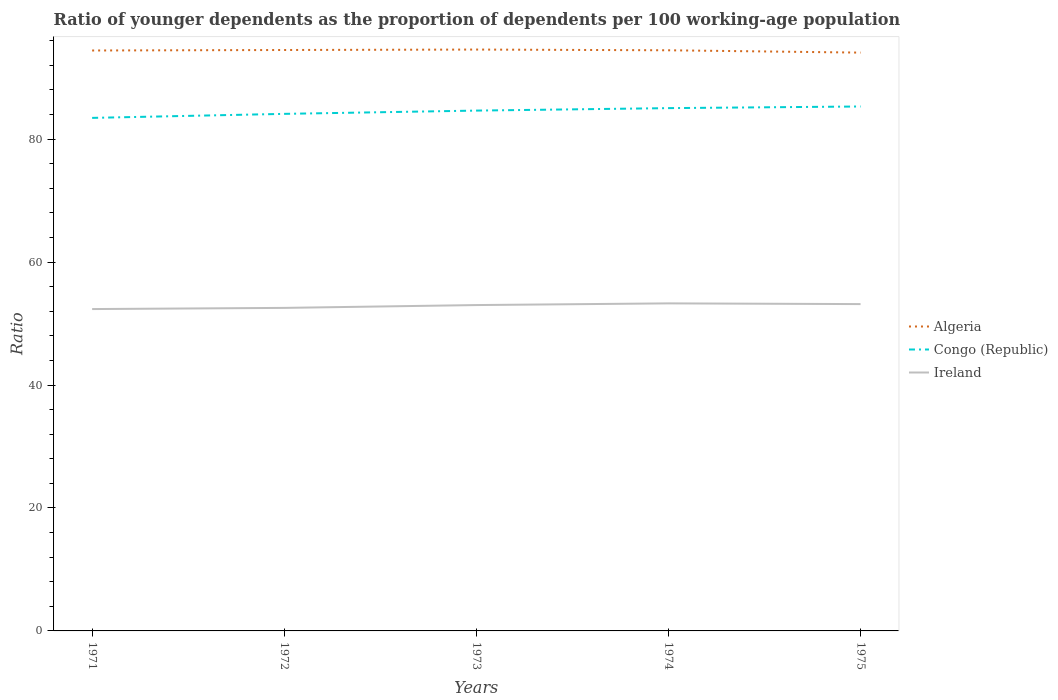Across all years, what is the maximum age dependency ratio(young) in Congo (Republic)?
Ensure brevity in your answer.  83.46. In which year was the age dependency ratio(young) in Congo (Republic) maximum?
Your response must be concise. 1971. What is the total age dependency ratio(young) in Congo (Republic) in the graph?
Ensure brevity in your answer.  -1.19. What is the difference between the highest and the second highest age dependency ratio(young) in Algeria?
Your answer should be very brief. 0.5. How many years are there in the graph?
Your answer should be compact. 5. What is the difference between two consecutive major ticks on the Y-axis?
Give a very brief answer. 20. Are the values on the major ticks of Y-axis written in scientific E-notation?
Your response must be concise. No. Does the graph contain grids?
Offer a terse response. No. Where does the legend appear in the graph?
Your response must be concise. Center right. How many legend labels are there?
Your answer should be very brief. 3. What is the title of the graph?
Your answer should be compact. Ratio of younger dependents as the proportion of dependents per 100 working-age population. Does "Indonesia" appear as one of the legend labels in the graph?
Offer a terse response. No. What is the label or title of the Y-axis?
Give a very brief answer. Ratio. What is the Ratio of Algeria in 1971?
Your answer should be very brief. 94.42. What is the Ratio of Congo (Republic) in 1971?
Give a very brief answer. 83.46. What is the Ratio of Ireland in 1971?
Offer a very short reply. 52.36. What is the Ratio of Algeria in 1972?
Offer a terse response. 94.5. What is the Ratio of Congo (Republic) in 1972?
Make the answer very short. 84.11. What is the Ratio of Ireland in 1972?
Keep it short and to the point. 52.55. What is the Ratio of Algeria in 1973?
Your answer should be compact. 94.57. What is the Ratio of Congo (Republic) in 1973?
Ensure brevity in your answer.  84.64. What is the Ratio of Ireland in 1973?
Give a very brief answer. 53.01. What is the Ratio in Algeria in 1974?
Give a very brief answer. 94.45. What is the Ratio in Congo (Republic) in 1974?
Provide a succinct answer. 85.04. What is the Ratio in Ireland in 1974?
Keep it short and to the point. 53.28. What is the Ratio in Algeria in 1975?
Ensure brevity in your answer.  94.07. What is the Ratio of Congo (Republic) in 1975?
Offer a very short reply. 85.31. What is the Ratio in Ireland in 1975?
Your response must be concise. 53.17. Across all years, what is the maximum Ratio in Algeria?
Provide a succinct answer. 94.57. Across all years, what is the maximum Ratio in Congo (Republic)?
Offer a very short reply. 85.31. Across all years, what is the maximum Ratio of Ireland?
Ensure brevity in your answer.  53.28. Across all years, what is the minimum Ratio in Algeria?
Your response must be concise. 94.07. Across all years, what is the minimum Ratio of Congo (Republic)?
Make the answer very short. 83.46. Across all years, what is the minimum Ratio of Ireland?
Provide a succinct answer. 52.36. What is the total Ratio of Algeria in the graph?
Provide a short and direct response. 472.02. What is the total Ratio of Congo (Republic) in the graph?
Offer a terse response. 422.57. What is the total Ratio in Ireland in the graph?
Make the answer very short. 264.36. What is the difference between the Ratio of Algeria in 1971 and that in 1972?
Your answer should be compact. -0.08. What is the difference between the Ratio of Congo (Republic) in 1971 and that in 1972?
Keep it short and to the point. -0.65. What is the difference between the Ratio of Ireland in 1971 and that in 1972?
Provide a short and direct response. -0.19. What is the difference between the Ratio in Algeria in 1971 and that in 1973?
Your response must be concise. -0.15. What is the difference between the Ratio of Congo (Republic) in 1971 and that in 1973?
Keep it short and to the point. -1.19. What is the difference between the Ratio of Ireland in 1971 and that in 1973?
Provide a succinct answer. -0.65. What is the difference between the Ratio of Algeria in 1971 and that in 1974?
Make the answer very short. -0.03. What is the difference between the Ratio of Congo (Republic) in 1971 and that in 1974?
Offer a terse response. -1.59. What is the difference between the Ratio of Ireland in 1971 and that in 1974?
Ensure brevity in your answer.  -0.92. What is the difference between the Ratio in Algeria in 1971 and that in 1975?
Your response must be concise. 0.35. What is the difference between the Ratio in Congo (Republic) in 1971 and that in 1975?
Provide a succinct answer. -1.85. What is the difference between the Ratio in Ireland in 1971 and that in 1975?
Keep it short and to the point. -0.81. What is the difference between the Ratio in Algeria in 1972 and that in 1973?
Your answer should be very brief. -0.07. What is the difference between the Ratio in Congo (Republic) in 1972 and that in 1973?
Your answer should be compact. -0.53. What is the difference between the Ratio of Ireland in 1972 and that in 1973?
Make the answer very short. -0.46. What is the difference between the Ratio in Algeria in 1972 and that in 1974?
Provide a short and direct response. 0.05. What is the difference between the Ratio in Congo (Republic) in 1972 and that in 1974?
Offer a terse response. -0.93. What is the difference between the Ratio of Ireland in 1972 and that in 1974?
Your response must be concise. -0.74. What is the difference between the Ratio of Algeria in 1972 and that in 1975?
Offer a terse response. 0.43. What is the difference between the Ratio of Congo (Republic) in 1972 and that in 1975?
Ensure brevity in your answer.  -1.2. What is the difference between the Ratio in Ireland in 1972 and that in 1975?
Give a very brief answer. -0.62. What is the difference between the Ratio of Algeria in 1973 and that in 1974?
Offer a terse response. 0.12. What is the difference between the Ratio of Congo (Republic) in 1973 and that in 1974?
Your answer should be compact. -0.4. What is the difference between the Ratio in Ireland in 1973 and that in 1974?
Make the answer very short. -0.27. What is the difference between the Ratio in Algeria in 1973 and that in 1975?
Provide a short and direct response. 0.5. What is the difference between the Ratio of Congo (Republic) in 1973 and that in 1975?
Offer a terse response. -0.67. What is the difference between the Ratio of Ireland in 1973 and that in 1975?
Give a very brief answer. -0.16. What is the difference between the Ratio in Algeria in 1974 and that in 1975?
Make the answer very short. 0.38. What is the difference between the Ratio of Congo (Republic) in 1974 and that in 1975?
Keep it short and to the point. -0.27. What is the difference between the Ratio of Ireland in 1974 and that in 1975?
Your answer should be very brief. 0.12. What is the difference between the Ratio of Algeria in 1971 and the Ratio of Congo (Republic) in 1972?
Make the answer very short. 10.31. What is the difference between the Ratio of Algeria in 1971 and the Ratio of Ireland in 1972?
Offer a very short reply. 41.87. What is the difference between the Ratio in Congo (Republic) in 1971 and the Ratio in Ireland in 1972?
Give a very brief answer. 30.91. What is the difference between the Ratio in Algeria in 1971 and the Ratio in Congo (Republic) in 1973?
Provide a short and direct response. 9.78. What is the difference between the Ratio of Algeria in 1971 and the Ratio of Ireland in 1973?
Make the answer very short. 41.41. What is the difference between the Ratio of Congo (Republic) in 1971 and the Ratio of Ireland in 1973?
Provide a short and direct response. 30.45. What is the difference between the Ratio in Algeria in 1971 and the Ratio in Congo (Republic) in 1974?
Your answer should be compact. 9.38. What is the difference between the Ratio of Algeria in 1971 and the Ratio of Ireland in 1974?
Keep it short and to the point. 41.14. What is the difference between the Ratio in Congo (Republic) in 1971 and the Ratio in Ireland in 1974?
Give a very brief answer. 30.17. What is the difference between the Ratio in Algeria in 1971 and the Ratio in Congo (Republic) in 1975?
Ensure brevity in your answer.  9.11. What is the difference between the Ratio of Algeria in 1971 and the Ratio of Ireland in 1975?
Offer a terse response. 41.25. What is the difference between the Ratio in Congo (Republic) in 1971 and the Ratio in Ireland in 1975?
Provide a succinct answer. 30.29. What is the difference between the Ratio of Algeria in 1972 and the Ratio of Congo (Republic) in 1973?
Give a very brief answer. 9.86. What is the difference between the Ratio of Algeria in 1972 and the Ratio of Ireland in 1973?
Offer a very short reply. 41.49. What is the difference between the Ratio in Congo (Republic) in 1972 and the Ratio in Ireland in 1973?
Provide a succinct answer. 31.1. What is the difference between the Ratio of Algeria in 1972 and the Ratio of Congo (Republic) in 1974?
Your response must be concise. 9.46. What is the difference between the Ratio of Algeria in 1972 and the Ratio of Ireland in 1974?
Ensure brevity in your answer.  41.22. What is the difference between the Ratio in Congo (Republic) in 1972 and the Ratio in Ireland in 1974?
Provide a short and direct response. 30.83. What is the difference between the Ratio in Algeria in 1972 and the Ratio in Congo (Republic) in 1975?
Offer a very short reply. 9.19. What is the difference between the Ratio of Algeria in 1972 and the Ratio of Ireland in 1975?
Provide a succinct answer. 41.34. What is the difference between the Ratio in Congo (Republic) in 1972 and the Ratio in Ireland in 1975?
Give a very brief answer. 30.95. What is the difference between the Ratio of Algeria in 1973 and the Ratio of Congo (Republic) in 1974?
Offer a very short reply. 9.53. What is the difference between the Ratio of Algeria in 1973 and the Ratio of Ireland in 1974?
Your answer should be compact. 41.29. What is the difference between the Ratio in Congo (Republic) in 1973 and the Ratio in Ireland in 1974?
Your answer should be very brief. 31.36. What is the difference between the Ratio in Algeria in 1973 and the Ratio in Congo (Republic) in 1975?
Keep it short and to the point. 9.26. What is the difference between the Ratio in Algeria in 1973 and the Ratio in Ireland in 1975?
Give a very brief answer. 41.41. What is the difference between the Ratio of Congo (Republic) in 1973 and the Ratio of Ireland in 1975?
Give a very brief answer. 31.48. What is the difference between the Ratio in Algeria in 1974 and the Ratio in Congo (Republic) in 1975?
Offer a very short reply. 9.14. What is the difference between the Ratio in Algeria in 1974 and the Ratio in Ireland in 1975?
Your response must be concise. 41.29. What is the difference between the Ratio in Congo (Republic) in 1974 and the Ratio in Ireland in 1975?
Your answer should be very brief. 31.88. What is the average Ratio in Algeria per year?
Provide a succinct answer. 94.4. What is the average Ratio of Congo (Republic) per year?
Make the answer very short. 84.51. What is the average Ratio of Ireland per year?
Your answer should be very brief. 52.87. In the year 1971, what is the difference between the Ratio in Algeria and Ratio in Congo (Republic)?
Offer a very short reply. 10.96. In the year 1971, what is the difference between the Ratio in Algeria and Ratio in Ireland?
Your answer should be very brief. 42.06. In the year 1971, what is the difference between the Ratio in Congo (Republic) and Ratio in Ireland?
Ensure brevity in your answer.  31.1. In the year 1972, what is the difference between the Ratio in Algeria and Ratio in Congo (Republic)?
Keep it short and to the point. 10.39. In the year 1972, what is the difference between the Ratio in Algeria and Ratio in Ireland?
Your response must be concise. 41.95. In the year 1972, what is the difference between the Ratio in Congo (Republic) and Ratio in Ireland?
Your answer should be very brief. 31.56. In the year 1973, what is the difference between the Ratio of Algeria and Ratio of Congo (Republic)?
Offer a very short reply. 9.93. In the year 1973, what is the difference between the Ratio of Algeria and Ratio of Ireland?
Provide a short and direct response. 41.56. In the year 1973, what is the difference between the Ratio of Congo (Republic) and Ratio of Ireland?
Your answer should be very brief. 31.63. In the year 1974, what is the difference between the Ratio in Algeria and Ratio in Congo (Republic)?
Offer a terse response. 9.41. In the year 1974, what is the difference between the Ratio in Algeria and Ratio in Ireland?
Make the answer very short. 41.17. In the year 1974, what is the difference between the Ratio of Congo (Republic) and Ratio of Ireland?
Provide a short and direct response. 31.76. In the year 1975, what is the difference between the Ratio in Algeria and Ratio in Congo (Republic)?
Your answer should be compact. 8.76. In the year 1975, what is the difference between the Ratio of Algeria and Ratio of Ireland?
Your answer should be very brief. 40.91. In the year 1975, what is the difference between the Ratio in Congo (Republic) and Ratio in Ireland?
Ensure brevity in your answer.  32.15. What is the ratio of the Ratio of Congo (Republic) in 1971 to that in 1972?
Your response must be concise. 0.99. What is the ratio of the Ratio of Algeria in 1971 to that in 1973?
Offer a terse response. 1. What is the ratio of the Ratio in Congo (Republic) in 1971 to that in 1973?
Keep it short and to the point. 0.99. What is the ratio of the Ratio in Ireland in 1971 to that in 1973?
Give a very brief answer. 0.99. What is the ratio of the Ratio in Algeria in 1971 to that in 1974?
Provide a succinct answer. 1. What is the ratio of the Ratio of Congo (Republic) in 1971 to that in 1974?
Ensure brevity in your answer.  0.98. What is the ratio of the Ratio in Ireland in 1971 to that in 1974?
Give a very brief answer. 0.98. What is the ratio of the Ratio of Algeria in 1971 to that in 1975?
Offer a terse response. 1. What is the ratio of the Ratio of Congo (Republic) in 1971 to that in 1975?
Give a very brief answer. 0.98. What is the ratio of the Ratio in Ireland in 1971 to that in 1975?
Keep it short and to the point. 0.98. What is the ratio of the Ratio of Algeria in 1972 to that in 1973?
Offer a terse response. 1. What is the ratio of the Ratio of Ireland in 1972 to that in 1974?
Your response must be concise. 0.99. What is the ratio of the Ratio of Congo (Republic) in 1972 to that in 1975?
Your response must be concise. 0.99. What is the ratio of the Ratio in Ireland in 1972 to that in 1975?
Provide a succinct answer. 0.99. What is the ratio of the Ratio in Algeria in 1973 to that in 1974?
Keep it short and to the point. 1. What is the ratio of the Ratio of Ireland in 1973 to that in 1974?
Your answer should be very brief. 0.99. What is the ratio of the Ratio of Algeria in 1973 to that in 1975?
Make the answer very short. 1.01. What is the ratio of the Ratio in Ireland in 1973 to that in 1975?
Give a very brief answer. 1. What is the ratio of the Ratio of Algeria in 1974 to that in 1975?
Ensure brevity in your answer.  1. What is the ratio of the Ratio in Congo (Republic) in 1974 to that in 1975?
Make the answer very short. 1. What is the ratio of the Ratio of Ireland in 1974 to that in 1975?
Your answer should be very brief. 1. What is the difference between the highest and the second highest Ratio in Algeria?
Offer a terse response. 0.07. What is the difference between the highest and the second highest Ratio in Congo (Republic)?
Give a very brief answer. 0.27. What is the difference between the highest and the second highest Ratio in Ireland?
Provide a short and direct response. 0.12. What is the difference between the highest and the lowest Ratio of Algeria?
Provide a succinct answer. 0.5. What is the difference between the highest and the lowest Ratio in Congo (Republic)?
Provide a succinct answer. 1.85. What is the difference between the highest and the lowest Ratio of Ireland?
Provide a succinct answer. 0.92. 